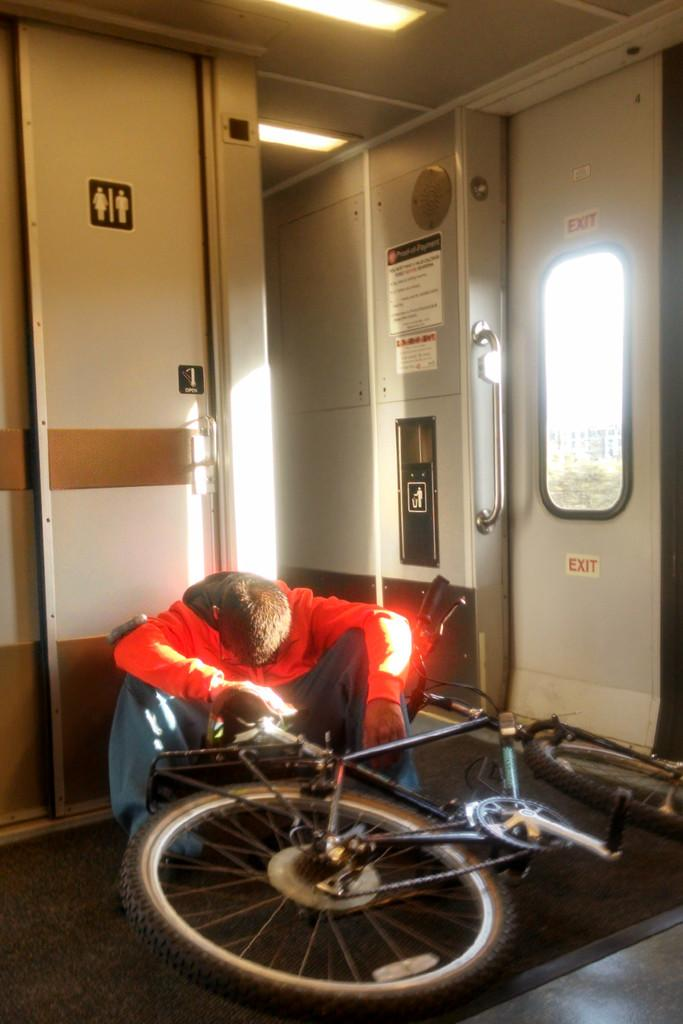What type of objects can be seen in the image? There are doors and bicycles in the image. Can you describe the person in the image? There is a person wearing a red color jacket in the image. What type of stove can be seen in the image? There is no stove present in the image. What can be seen from the person's viewpoint in the image? The provided facts do not give information about the person's viewpoint, so it cannot be determined from the image. 